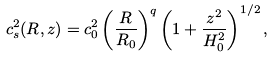<formula> <loc_0><loc_0><loc_500><loc_500>c _ { s } ^ { 2 } ( R , z ) = c _ { 0 } ^ { 2 } \left ( \frac { R } { R _ { 0 } } \right ) ^ { q } \left ( 1 + \frac { z ^ { 2 } } { H _ { 0 } ^ { 2 } } \right ) ^ { 1 / 2 } ,</formula> 